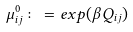<formula> <loc_0><loc_0><loc_500><loc_500>\mu _ { i j } ^ { 0 } \colon = e x p ( \beta Q _ { i j } )</formula> 